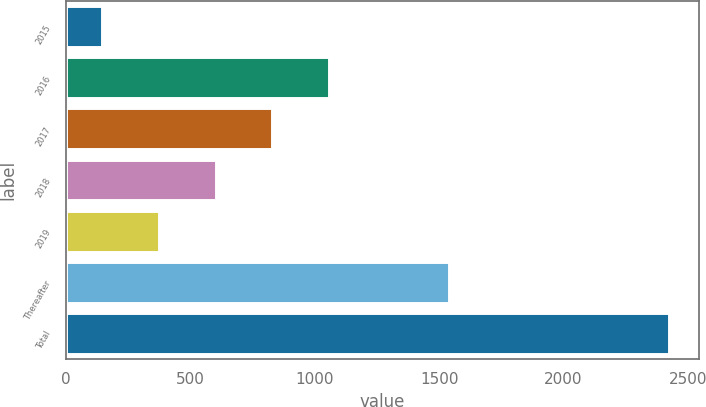Convert chart to OTSL. <chart><loc_0><loc_0><loc_500><loc_500><bar_chart><fcel>2015<fcel>2016<fcel>2017<fcel>2018<fcel>2019<fcel>Thereafter<fcel>Total<nl><fcel>145.6<fcel>1056.68<fcel>828.91<fcel>601.14<fcel>373.37<fcel>1540.5<fcel>2423.3<nl></chart> 